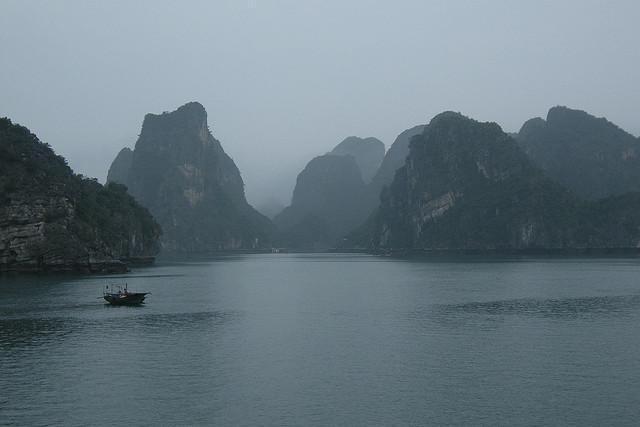How many boats on the water?
Give a very brief answer. 1. How many of the cats paws are on the desk?
Give a very brief answer. 0. 